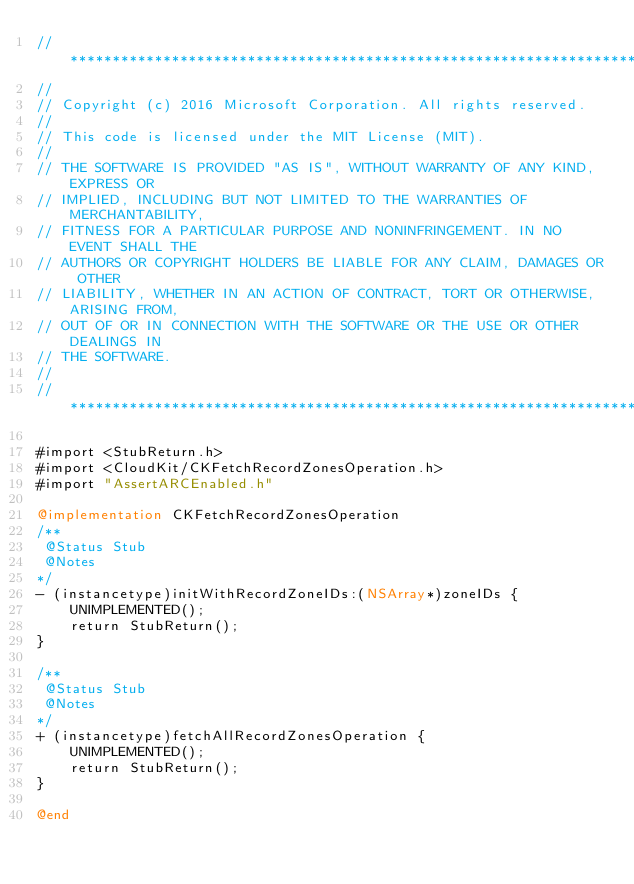Convert code to text. <code><loc_0><loc_0><loc_500><loc_500><_ObjectiveC_>//******************************************************************************
//
// Copyright (c) 2016 Microsoft Corporation. All rights reserved.
//
// This code is licensed under the MIT License (MIT).
//
// THE SOFTWARE IS PROVIDED "AS IS", WITHOUT WARRANTY OF ANY KIND, EXPRESS OR
// IMPLIED, INCLUDING BUT NOT LIMITED TO THE WARRANTIES OF MERCHANTABILITY,
// FITNESS FOR A PARTICULAR PURPOSE AND NONINFRINGEMENT. IN NO EVENT SHALL THE
// AUTHORS OR COPYRIGHT HOLDERS BE LIABLE FOR ANY CLAIM, DAMAGES OR OTHER
// LIABILITY, WHETHER IN AN ACTION OF CONTRACT, TORT OR OTHERWISE, ARISING FROM,
// OUT OF OR IN CONNECTION WITH THE SOFTWARE OR THE USE OR OTHER DEALINGS IN
// THE SOFTWARE.
//
//******************************************************************************

#import <StubReturn.h>
#import <CloudKit/CKFetchRecordZonesOperation.h>
#import "AssertARCEnabled.h"

@implementation CKFetchRecordZonesOperation
/**
 @Status Stub
 @Notes
*/
- (instancetype)initWithRecordZoneIDs:(NSArray*)zoneIDs {
    UNIMPLEMENTED();
    return StubReturn();
}

/**
 @Status Stub
 @Notes
*/
+ (instancetype)fetchAllRecordZonesOperation {
    UNIMPLEMENTED();
    return StubReturn();
}

@end
</code> 